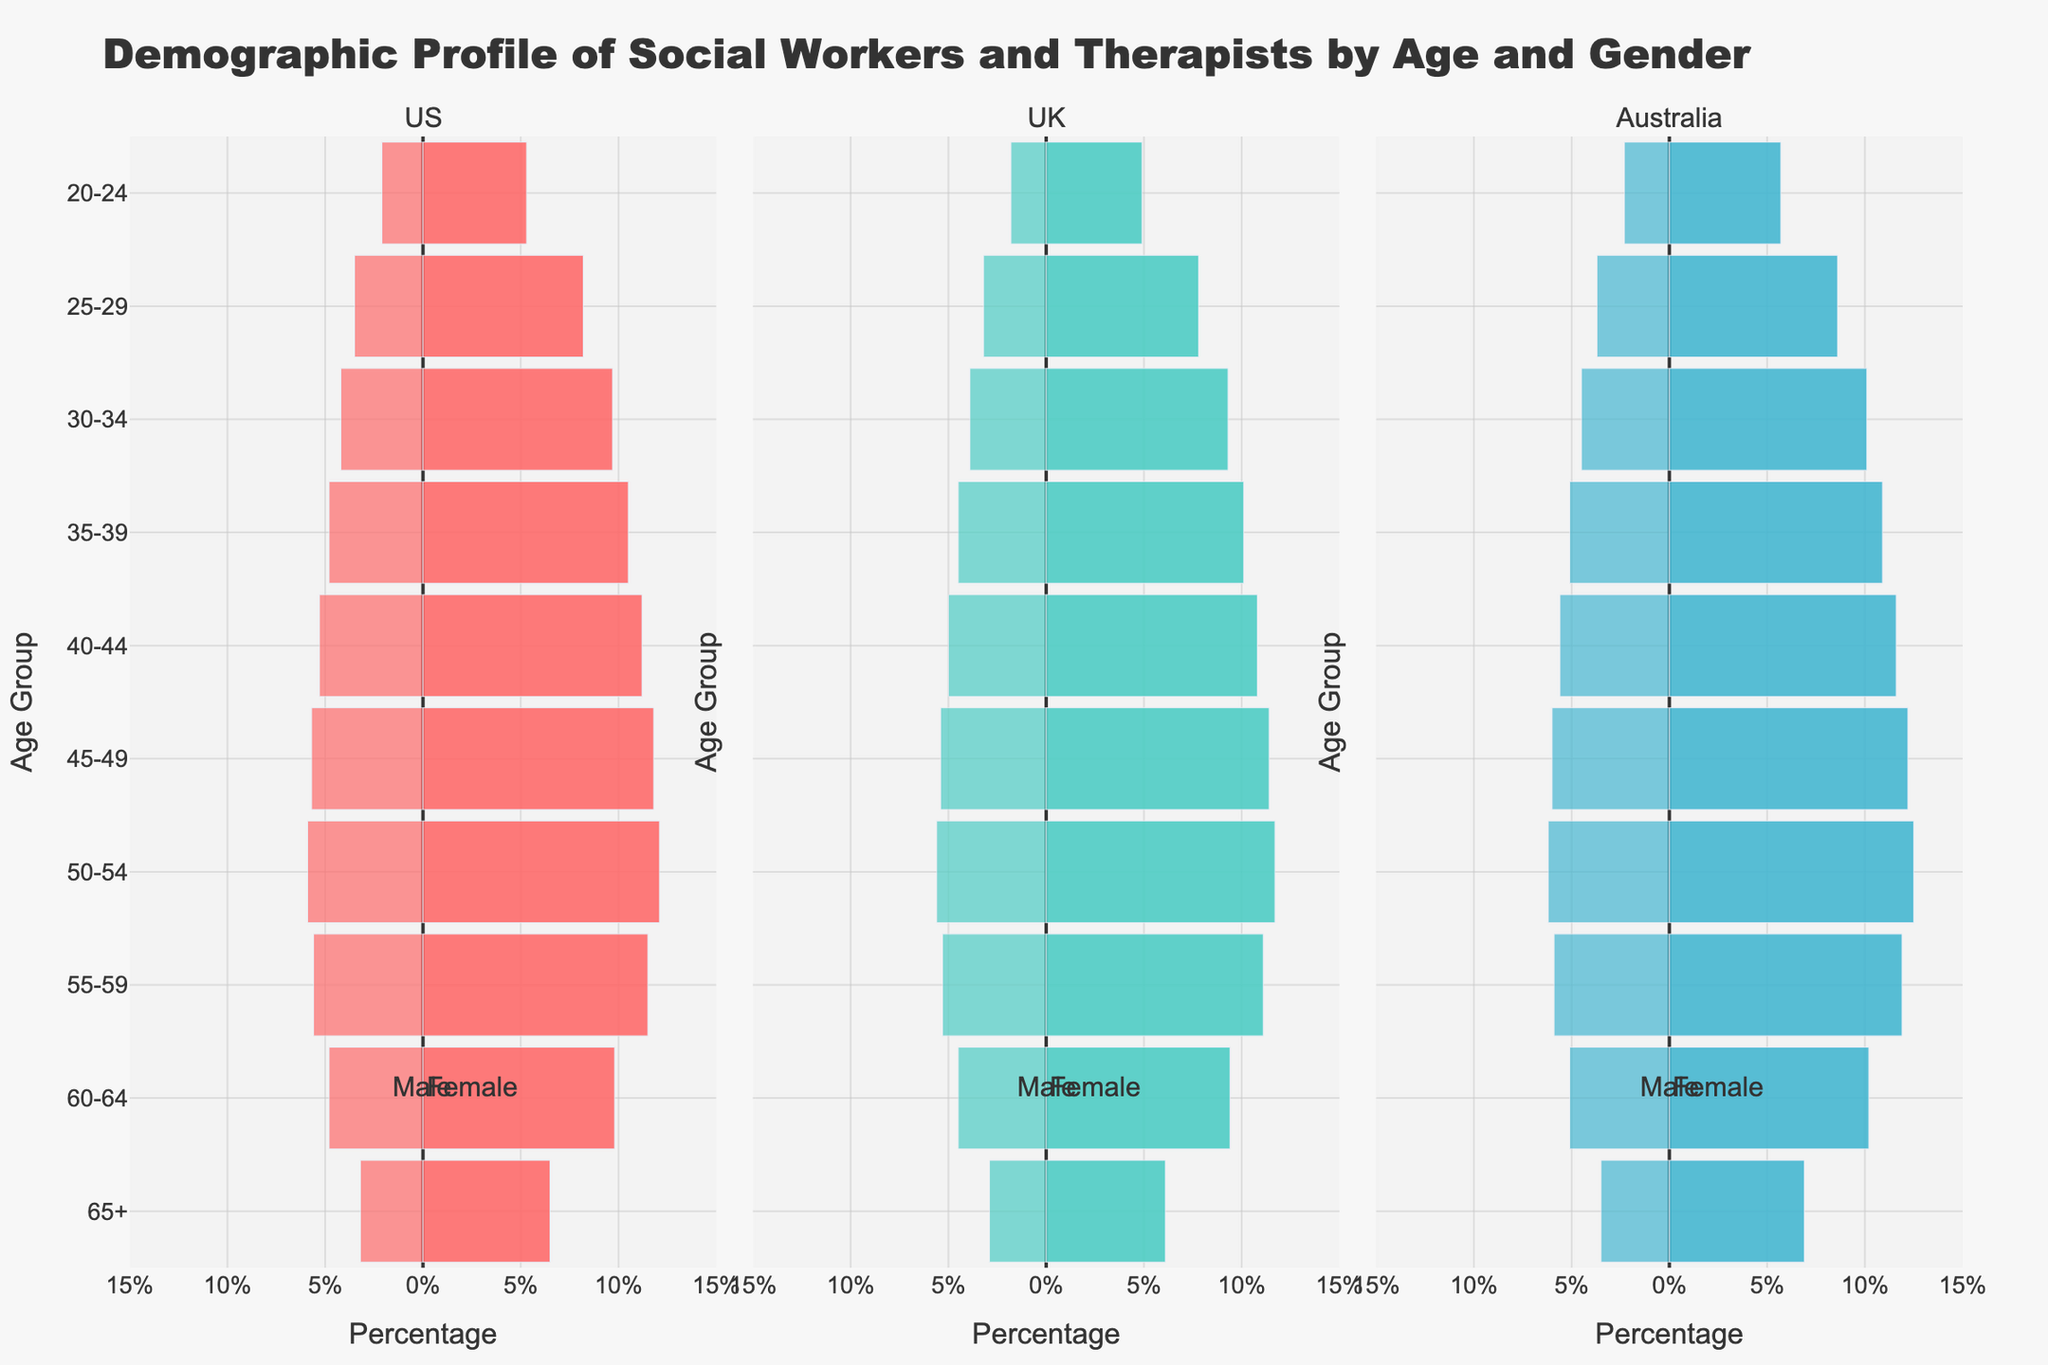What is the title of the plot? The title is displayed at the top of the plot. It states the main subject or theme of the figure.
Answer: Demographic Profile of Social Workers and Therapists by Age and Gender Which country has the highest percentage of female social workers aged 45-49? Locate the bar for the age group 45-49 and compare the lengths of the female bars for each country.
Answer: Australia How does the percentage of male social workers aged 20-24 in the UK compare to those in the US? Look at the bars for males aged 20-24 for both UK and US, compare the lengths.
Answer: Lower Between the age groups 35-39 and 55-59, which has a higher percentage of female social workers in the US? Compare the lengths of the bars for females aged 35-39 and 55-59 in the US.
Answer: 55-59 What is the age group with the highest percentage of male social workers in Australia? Identify the longest bar for male social workers across all age groups in Australia.
Answer: 50-54 Compare the percentage of female social workers aged 25-29 in the UK and Australia. Look at and compare the lengths of the bars for females aged 25-29 in both UK and Australia.
Answer: Higher in Australia What percentage of female social workers are there in the 65+ age group in the UK? Locate the bar indicating the percentage of females aged 65+ in the UK and read the value.
Answer: 6.1% Which age group has an equal percentage of male and female social workers in the US? Compare the lengths of male and female bars across all age groups in the US and find the one with equal lengths.
Answer: No age group has equal percentage Which gender has a higher representation in the age group 40-44 in Australia? Compare the lengths of the male and female bars for the age group 40-44 in Australia.
Answer: Female What is the difference in the percentage of male social workers aged 55-59 compared to those aged 60-64 in the US? Subtract the value of the percentage of males aged 60-64 from the value of males aged 55-59 in the US.
Answer: 0.8% 